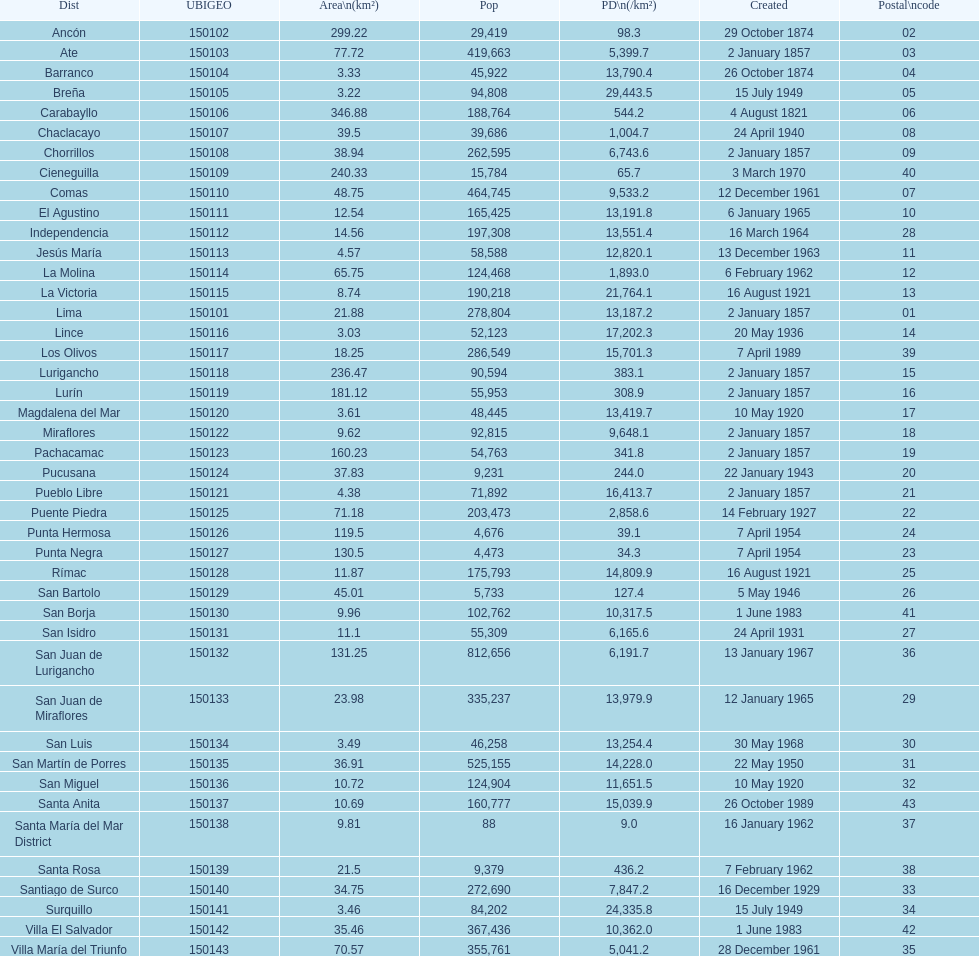What was the last district created? Santa Anita. 